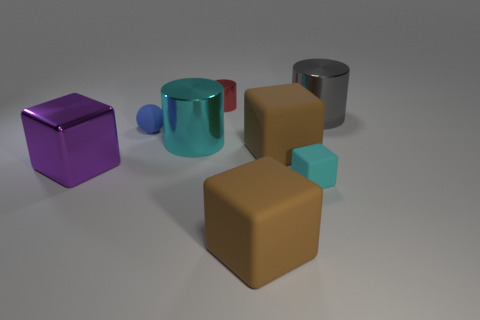Add 1 large brown matte things. How many objects exist? 9 Subtract all balls. How many objects are left? 7 Add 2 small metal objects. How many small metal objects are left? 3 Add 5 big cyan metal cylinders. How many big cyan metal cylinders exist? 6 Subtract 0 gray blocks. How many objects are left? 8 Subtract all brown rubber objects. Subtract all small red metallic things. How many objects are left? 5 